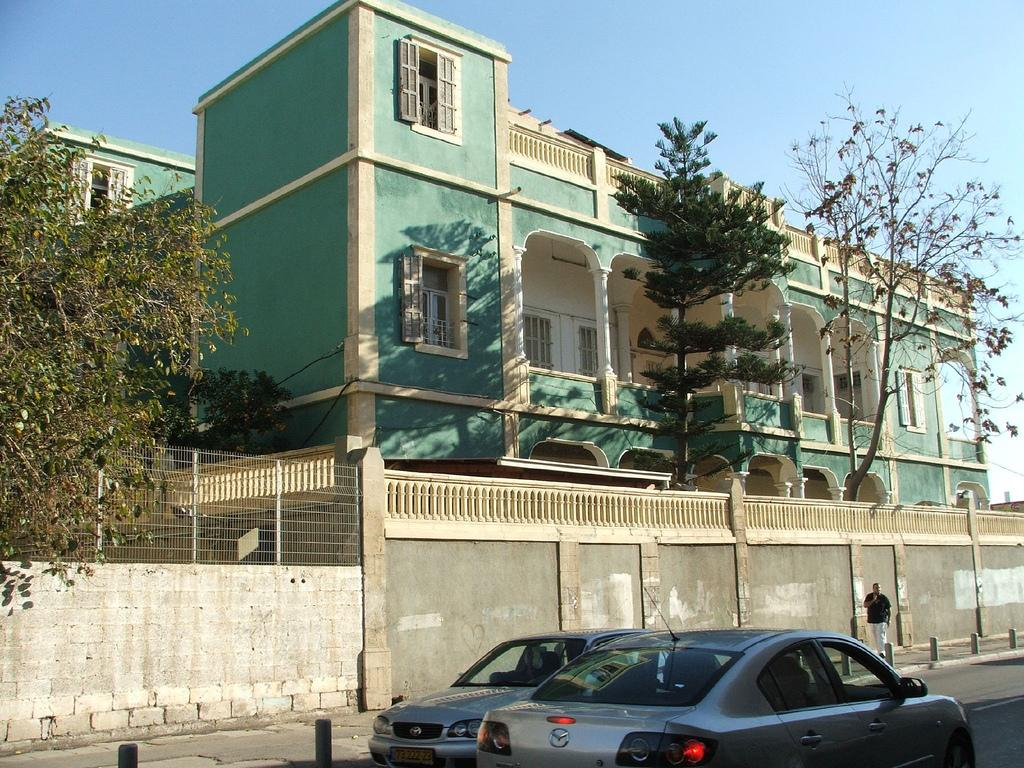What type of structures can be seen in the image? There are buildings in the image. What natural elements are present in the image? There are trees in the image. What type of barrier can be seen in the image? There is a fence in the image. What type of vehicles are present in the image? There are cars in the image. What activity is a person engaged in within the image? There is a person walking in the image. What is visible in the background of the image? The sky is visible in the image. Where is the crayon being used in the image? There is no crayon present in the image. What type of winter accessory is being worn by the person walking in the image? There is no winter accessory visible in the image, as the person walking is not wearing a mitten or any other type of winter clothing. 